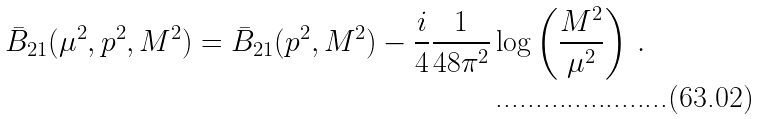<formula> <loc_0><loc_0><loc_500><loc_500>\bar { B } _ { 2 1 } ( \mu ^ { 2 } , p ^ { 2 } , M ^ { 2 } ) = \bar { B } _ { 2 1 } ( p ^ { 2 } , M ^ { 2 } ) - \frac { i } { 4 } \frac { 1 } { 4 8 \pi ^ { 2 } } \log \left ( \frac { M ^ { 2 } } { \mu ^ { 2 } } \right ) \, .</formula> 